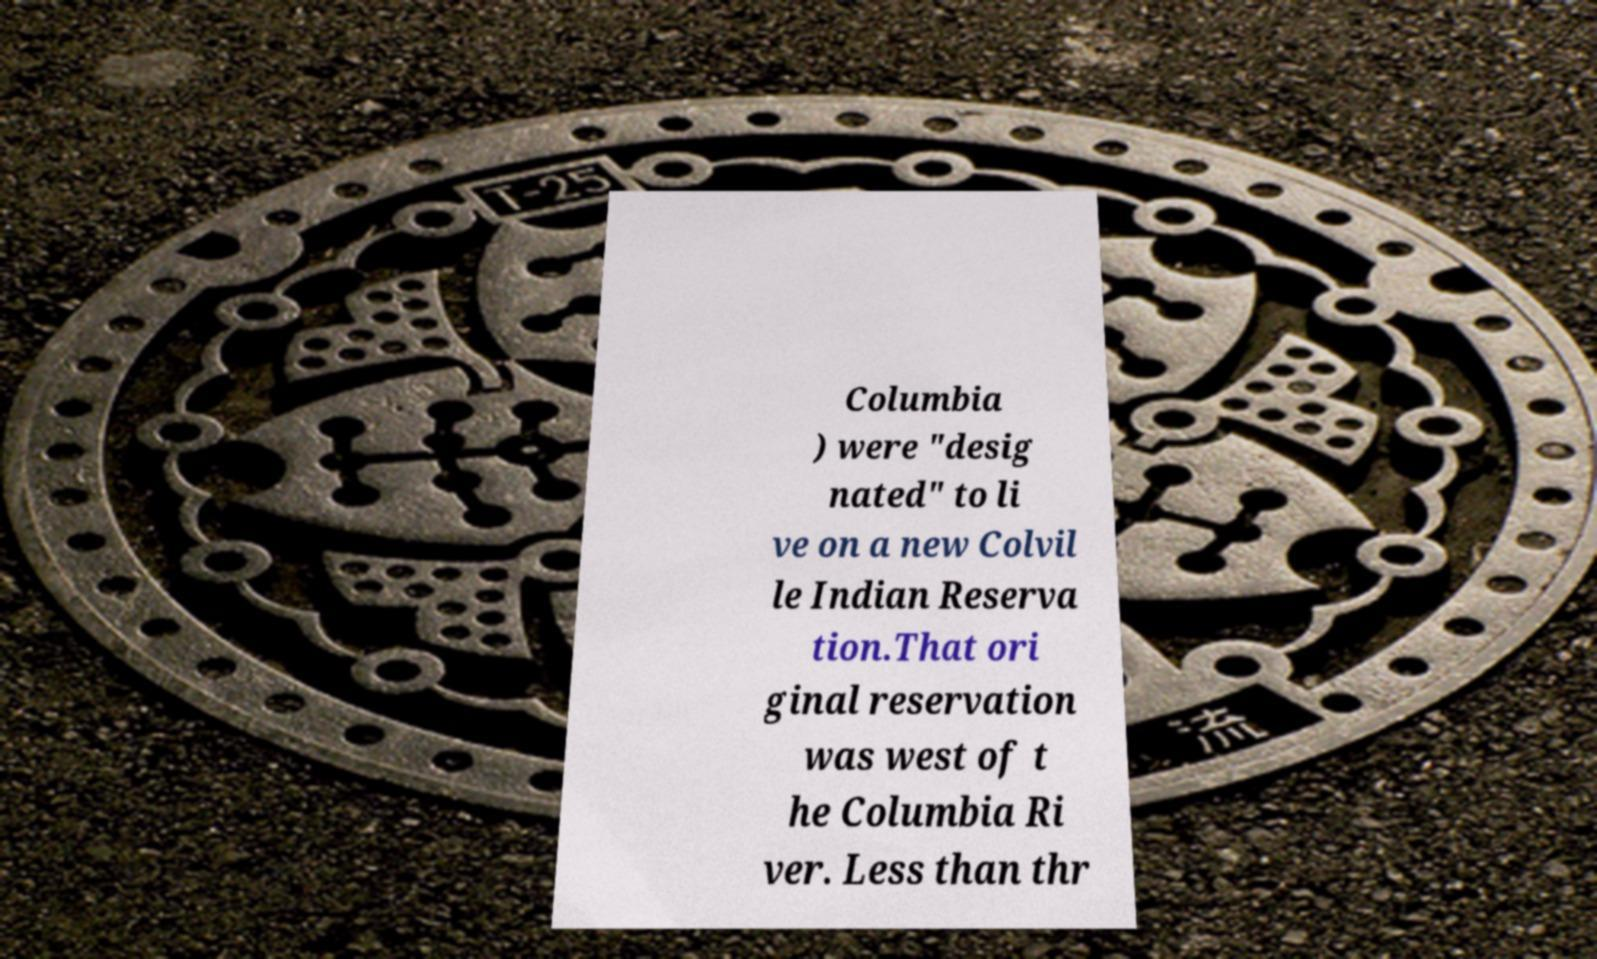What messages or text are displayed in this image? I need them in a readable, typed format. Columbia ) were "desig nated" to li ve on a new Colvil le Indian Reserva tion.That ori ginal reservation was west of t he Columbia Ri ver. Less than thr 